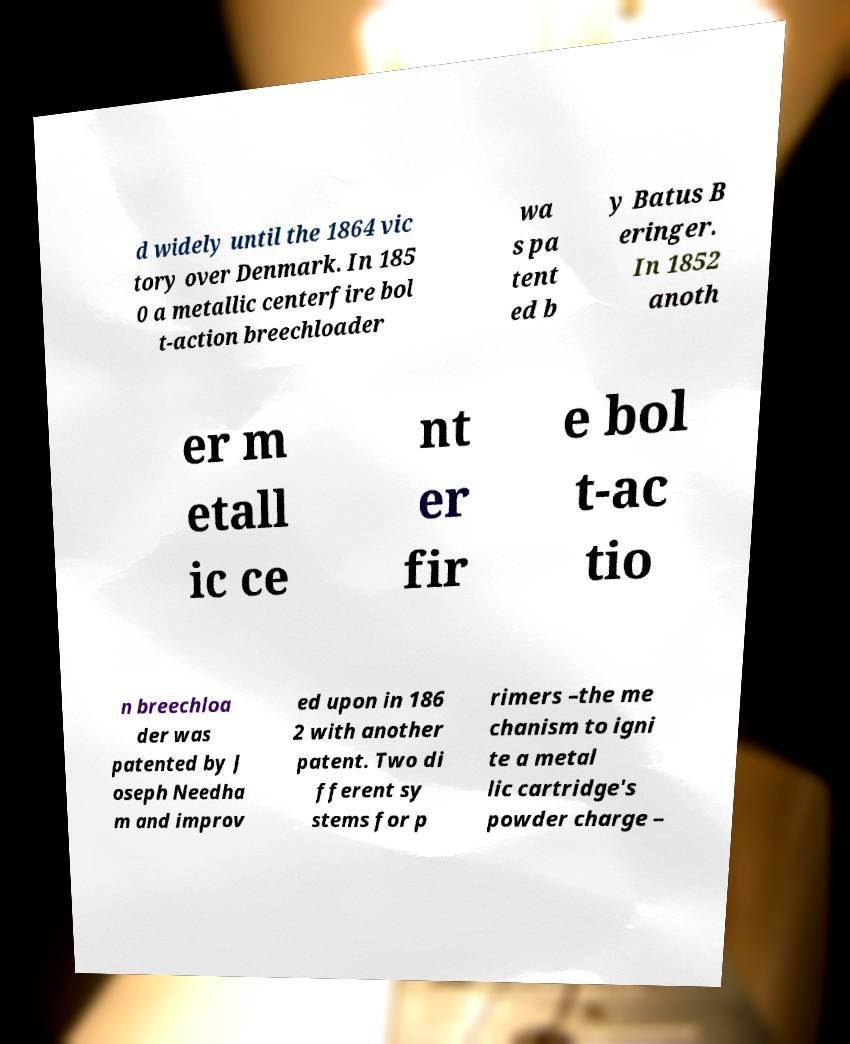Can you read and provide the text displayed in the image?This photo seems to have some interesting text. Can you extract and type it out for me? d widely until the 1864 vic tory over Denmark. In 185 0 a metallic centerfire bol t-action breechloader wa s pa tent ed b y Batus B eringer. In 1852 anoth er m etall ic ce nt er fir e bol t-ac tio n breechloa der was patented by J oseph Needha m and improv ed upon in 186 2 with another patent. Two di fferent sy stems for p rimers –the me chanism to igni te a metal lic cartridge's powder charge – 